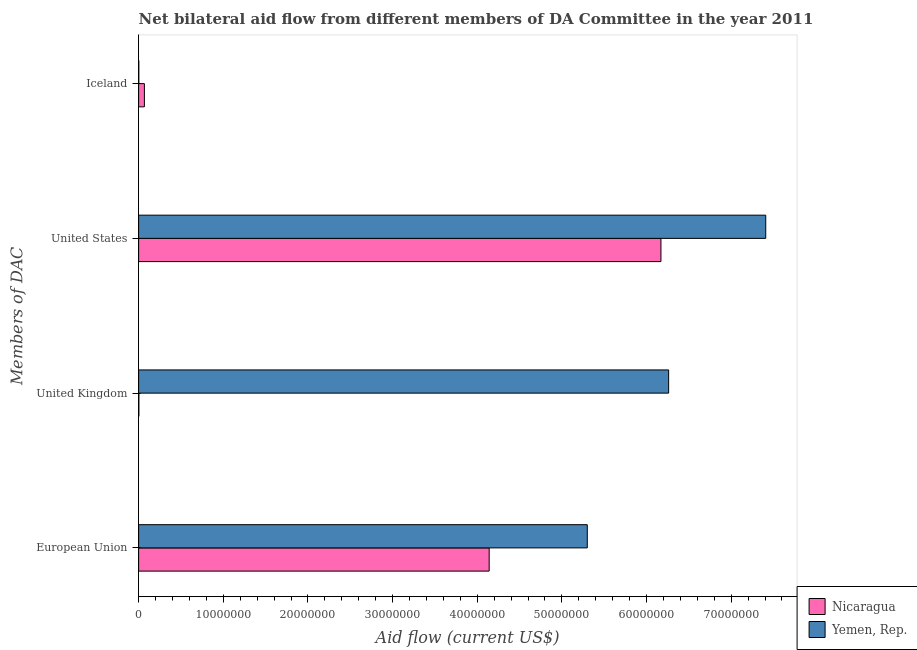How many different coloured bars are there?
Your answer should be compact. 2. How many bars are there on the 4th tick from the bottom?
Give a very brief answer. 2. What is the amount of aid given by iceland in Yemen, Rep.?
Your answer should be compact. 2.00e+04. Across all countries, what is the maximum amount of aid given by us?
Your answer should be very brief. 7.41e+07. Across all countries, what is the minimum amount of aid given by iceland?
Your answer should be compact. 2.00e+04. In which country was the amount of aid given by iceland maximum?
Make the answer very short. Nicaragua. In which country was the amount of aid given by uk minimum?
Provide a short and direct response. Nicaragua. What is the total amount of aid given by us in the graph?
Offer a very short reply. 1.36e+08. What is the difference between the amount of aid given by eu in Yemen, Rep. and that in Nicaragua?
Provide a short and direct response. 1.16e+07. What is the difference between the amount of aid given by uk in Nicaragua and the amount of aid given by us in Yemen, Rep.?
Provide a short and direct response. -7.40e+07. What is the difference between the amount of aid given by iceland and amount of aid given by us in Yemen, Rep.?
Provide a succinct answer. -7.41e+07. What is the difference between the highest and the second highest amount of aid given by uk?
Provide a succinct answer. 6.26e+07. What is the difference between the highest and the lowest amount of aid given by uk?
Give a very brief answer. 6.26e+07. Is it the case that in every country, the sum of the amount of aid given by uk and amount of aid given by eu is greater than the sum of amount of aid given by us and amount of aid given by iceland?
Your response must be concise. Yes. What does the 2nd bar from the top in Iceland represents?
Give a very brief answer. Nicaragua. What does the 1st bar from the bottom in United Kingdom represents?
Offer a terse response. Nicaragua. Is it the case that in every country, the sum of the amount of aid given by eu and amount of aid given by uk is greater than the amount of aid given by us?
Give a very brief answer. No. Are all the bars in the graph horizontal?
Provide a short and direct response. Yes. What is the difference between two consecutive major ticks on the X-axis?
Offer a terse response. 1.00e+07. Are the values on the major ticks of X-axis written in scientific E-notation?
Your answer should be very brief. No. How are the legend labels stacked?
Keep it short and to the point. Vertical. What is the title of the graph?
Provide a short and direct response. Net bilateral aid flow from different members of DA Committee in the year 2011. What is the label or title of the X-axis?
Make the answer very short. Aid flow (current US$). What is the label or title of the Y-axis?
Keep it short and to the point. Members of DAC. What is the Aid flow (current US$) of Nicaragua in European Union?
Make the answer very short. 4.14e+07. What is the Aid flow (current US$) in Yemen, Rep. in European Union?
Provide a short and direct response. 5.30e+07. What is the Aid flow (current US$) in Yemen, Rep. in United Kingdom?
Provide a short and direct response. 6.26e+07. What is the Aid flow (current US$) of Nicaragua in United States?
Provide a short and direct response. 6.17e+07. What is the Aid flow (current US$) of Yemen, Rep. in United States?
Your response must be concise. 7.41e+07. What is the Aid flow (current US$) in Nicaragua in Iceland?
Your answer should be compact. 6.80e+05. What is the Aid flow (current US$) in Yemen, Rep. in Iceland?
Offer a very short reply. 2.00e+04. Across all Members of DAC, what is the maximum Aid flow (current US$) in Nicaragua?
Provide a short and direct response. 6.17e+07. Across all Members of DAC, what is the maximum Aid flow (current US$) in Yemen, Rep.?
Your answer should be compact. 7.41e+07. What is the total Aid flow (current US$) of Nicaragua in the graph?
Provide a succinct answer. 1.04e+08. What is the total Aid flow (current US$) in Yemen, Rep. in the graph?
Offer a terse response. 1.90e+08. What is the difference between the Aid flow (current US$) of Nicaragua in European Union and that in United Kingdom?
Make the answer very short. 4.14e+07. What is the difference between the Aid flow (current US$) of Yemen, Rep. in European Union and that in United Kingdom?
Your answer should be very brief. -9.61e+06. What is the difference between the Aid flow (current US$) of Nicaragua in European Union and that in United States?
Provide a short and direct response. -2.03e+07. What is the difference between the Aid flow (current US$) in Yemen, Rep. in European Union and that in United States?
Your answer should be very brief. -2.11e+07. What is the difference between the Aid flow (current US$) in Nicaragua in European Union and that in Iceland?
Keep it short and to the point. 4.07e+07. What is the difference between the Aid flow (current US$) of Yemen, Rep. in European Union and that in Iceland?
Ensure brevity in your answer.  5.30e+07. What is the difference between the Aid flow (current US$) in Nicaragua in United Kingdom and that in United States?
Keep it short and to the point. -6.17e+07. What is the difference between the Aid flow (current US$) of Yemen, Rep. in United Kingdom and that in United States?
Give a very brief answer. -1.15e+07. What is the difference between the Aid flow (current US$) of Nicaragua in United Kingdom and that in Iceland?
Offer a terse response. -6.50e+05. What is the difference between the Aid flow (current US$) in Yemen, Rep. in United Kingdom and that in Iceland?
Offer a very short reply. 6.26e+07. What is the difference between the Aid flow (current US$) in Nicaragua in United States and that in Iceland?
Ensure brevity in your answer.  6.10e+07. What is the difference between the Aid flow (current US$) of Yemen, Rep. in United States and that in Iceland?
Provide a succinct answer. 7.41e+07. What is the difference between the Aid flow (current US$) in Nicaragua in European Union and the Aid flow (current US$) in Yemen, Rep. in United Kingdom?
Make the answer very short. -2.12e+07. What is the difference between the Aid flow (current US$) in Nicaragua in European Union and the Aid flow (current US$) in Yemen, Rep. in United States?
Your response must be concise. -3.27e+07. What is the difference between the Aid flow (current US$) in Nicaragua in European Union and the Aid flow (current US$) in Yemen, Rep. in Iceland?
Your answer should be very brief. 4.14e+07. What is the difference between the Aid flow (current US$) of Nicaragua in United Kingdom and the Aid flow (current US$) of Yemen, Rep. in United States?
Give a very brief answer. -7.40e+07. What is the difference between the Aid flow (current US$) in Nicaragua in United Kingdom and the Aid flow (current US$) in Yemen, Rep. in Iceland?
Provide a short and direct response. 10000. What is the difference between the Aid flow (current US$) of Nicaragua in United States and the Aid flow (current US$) of Yemen, Rep. in Iceland?
Ensure brevity in your answer.  6.17e+07. What is the average Aid flow (current US$) of Nicaragua per Members of DAC?
Offer a very short reply. 2.60e+07. What is the average Aid flow (current US$) of Yemen, Rep. per Members of DAC?
Keep it short and to the point. 4.74e+07. What is the difference between the Aid flow (current US$) in Nicaragua and Aid flow (current US$) in Yemen, Rep. in European Union?
Offer a very short reply. -1.16e+07. What is the difference between the Aid flow (current US$) in Nicaragua and Aid flow (current US$) in Yemen, Rep. in United Kingdom?
Your answer should be very brief. -6.26e+07. What is the difference between the Aid flow (current US$) in Nicaragua and Aid flow (current US$) in Yemen, Rep. in United States?
Provide a succinct answer. -1.24e+07. What is the ratio of the Aid flow (current US$) in Nicaragua in European Union to that in United Kingdom?
Offer a very short reply. 1380.33. What is the ratio of the Aid flow (current US$) of Yemen, Rep. in European Union to that in United Kingdom?
Provide a short and direct response. 0.85. What is the ratio of the Aid flow (current US$) in Nicaragua in European Union to that in United States?
Your answer should be compact. 0.67. What is the ratio of the Aid flow (current US$) in Yemen, Rep. in European Union to that in United States?
Offer a very short reply. 0.72. What is the ratio of the Aid flow (current US$) in Nicaragua in European Union to that in Iceland?
Offer a very short reply. 60.9. What is the ratio of the Aid flow (current US$) in Yemen, Rep. in European Union to that in Iceland?
Offer a very short reply. 2650. What is the ratio of the Aid flow (current US$) of Yemen, Rep. in United Kingdom to that in United States?
Offer a very short reply. 0.85. What is the ratio of the Aid flow (current US$) in Nicaragua in United Kingdom to that in Iceland?
Provide a succinct answer. 0.04. What is the ratio of the Aid flow (current US$) of Yemen, Rep. in United Kingdom to that in Iceland?
Provide a short and direct response. 3130.5. What is the ratio of the Aid flow (current US$) in Nicaragua in United States to that in Iceland?
Provide a succinct answer. 90.74. What is the ratio of the Aid flow (current US$) of Yemen, Rep. in United States to that in Iceland?
Offer a terse response. 3704. What is the difference between the highest and the second highest Aid flow (current US$) of Nicaragua?
Provide a succinct answer. 2.03e+07. What is the difference between the highest and the second highest Aid flow (current US$) in Yemen, Rep.?
Your response must be concise. 1.15e+07. What is the difference between the highest and the lowest Aid flow (current US$) in Nicaragua?
Provide a succinct answer. 6.17e+07. What is the difference between the highest and the lowest Aid flow (current US$) in Yemen, Rep.?
Offer a very short reply. 7.41e+07. 